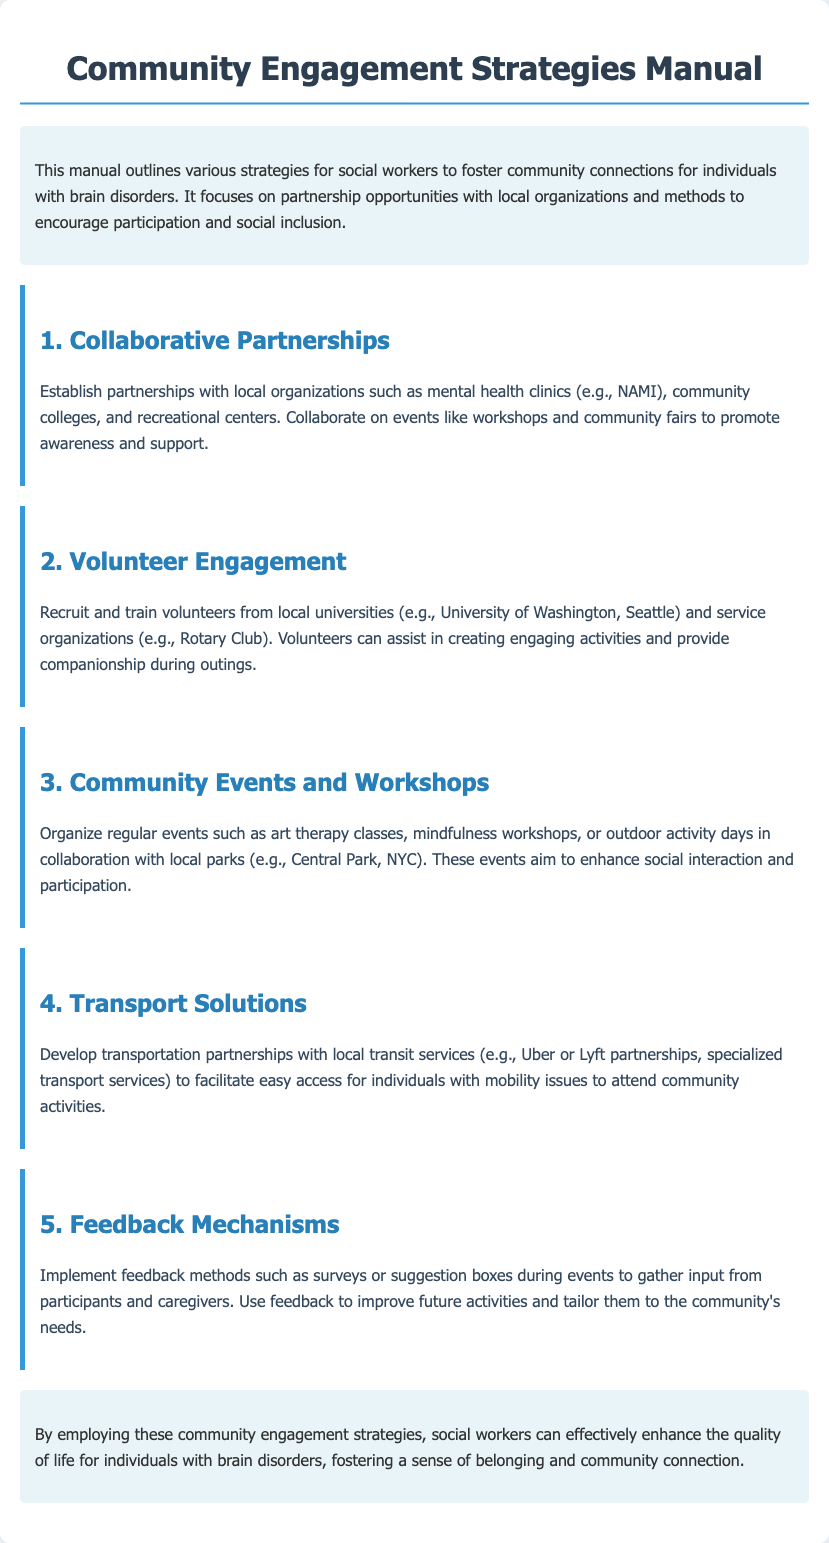What is the title of the manual? The title is the primary heading of the document, which introduces the content.
Answer: Community Engagement Strategies Manual What is one method for fostering social inclusion? The document lists various strategies, one of which includes organizing events that encourage social interaction.
Answer: Community Events and Workshops Which local organizations should be partnered with? The document mentions specific types of organizations to collaborate with for community activities.
Answer: Mental health clinics What is the purpose of feedback mechanisms? The document explains that these mechanisms are used to gather input from participants to improve future activities.
Answer: Improve future activities Name a type of event mentioned in the strategies. The document includes details about various activities aimed at engaging the community and includes specific examples.
Answer: Art therapy classes What is a transportation solution suggested in the manual? The manual recommends creating partnerships with certain services to solve accessibility issues for participants.
Answer: Uber or Lyft partnerships What is the goal of collaborative partnerships? The document indicates that the purpose of these partnerships is to promote awareness and support through joint efforts.
Answer: Promote awareness and support How many main strategies are outlined in the manual? By counting the distinct strategies listed in the document, we can identify the total number discussed.
Answer: Five 